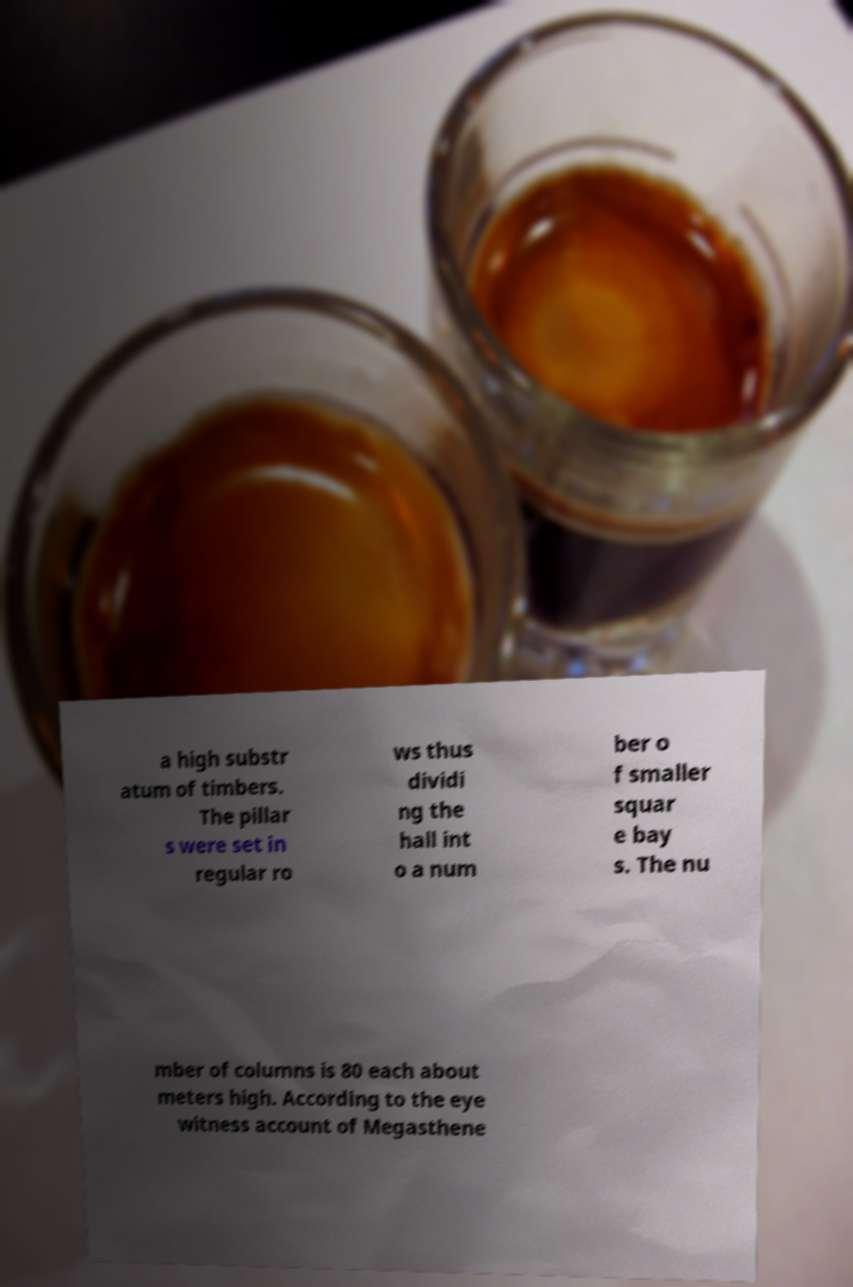For documentation purposes, I need the text within this image transcribed. Could you provide that? a high substr atum of timbers. The pillar s were set in regular ro ws thus dividi ng the hall int o a num ber o f smaller squar e bay s. The nu mber of columns is 80 each about meters high. According to the eye witness account of Megasthene 